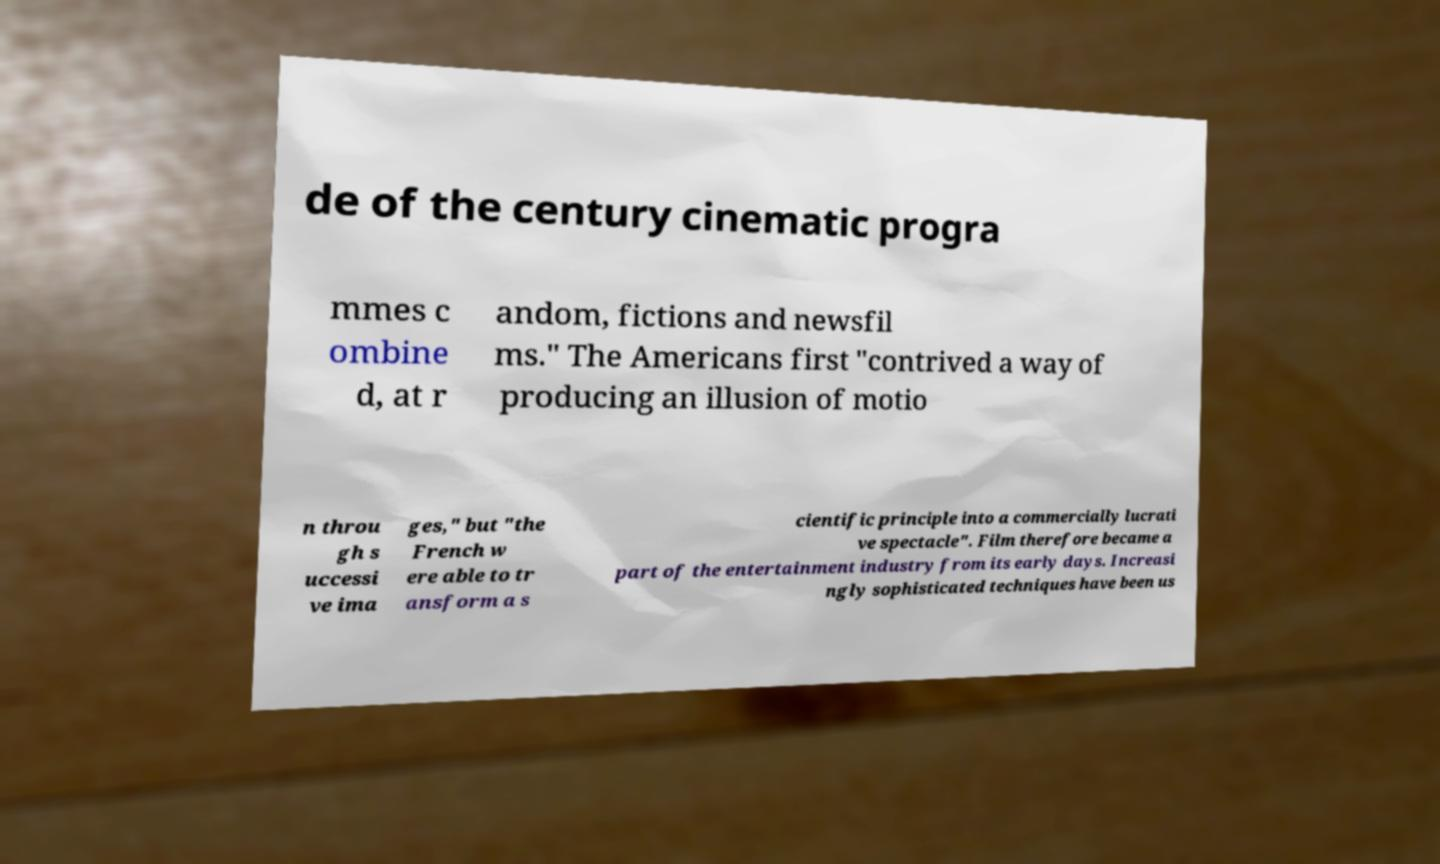For documentation purposes, I need the text within this image transcribed. Could you provide that? de of the century cinematic progra mmes c ombine d, at r andom, fictions and newsfil ms." The Americans first "contrived a way of producing an illusion of motio n throu gh s uccessi ve ima ges," but "the French w ere able to tr ansform a s cientific principle into a commercially lucrati ve spectacle". Film therefore became a part of the entertainment industry from its early days. Increasi ngly sophisticated techniques have been us 